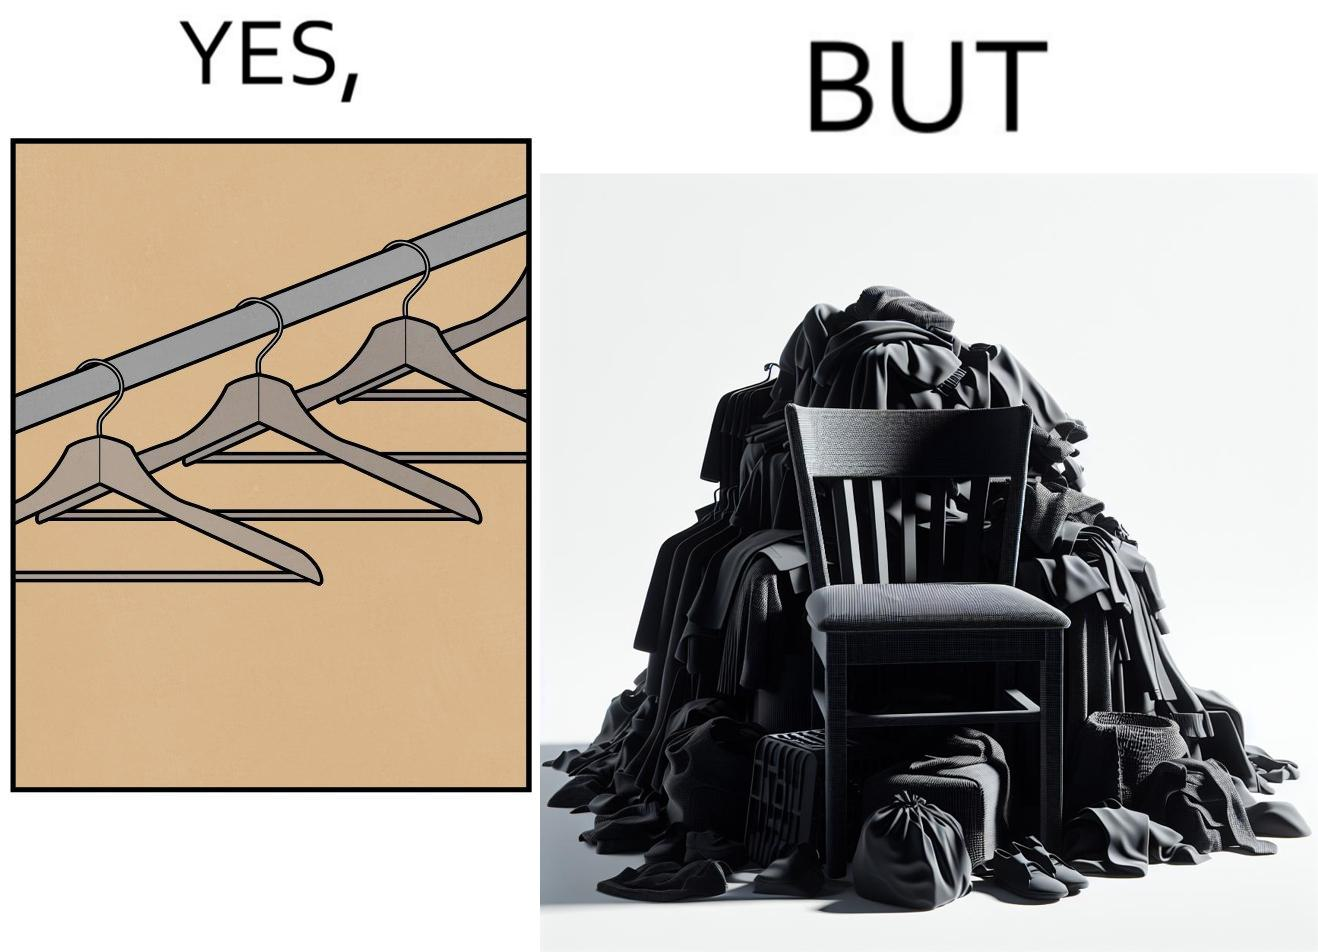Why is this image considered satirical? the image highlights irony when people make expensive and fancy wardrobes just to end up stacking all the clothes on a chair 